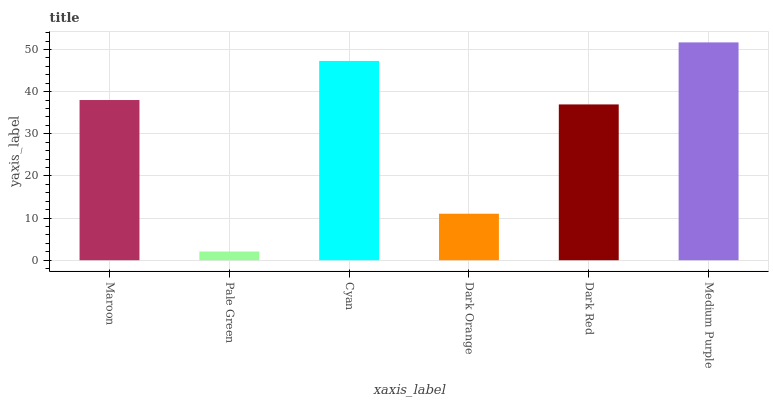Is Pale Green the minimum?
Answer yes or no. Yes. Is Medium Purple the maximum?
Answer yes or no. Yes. Is Cyan the minimum?
Answer yes or no. No. Is Cyan the maximum?
Answer yes or no. No. Is Cyan greater than Pale Green?
Answer yes or no. Yes. Is Pale Green less than Cyan?
Answer yes or no. Yes. Is Pale Green greater than Cyan?
Answer yes or no. No. Is Cyan less than Pale Green?
Answer yes or no. No. Is Maroon the high median?
Answer yes or no. Yes. Is Dark Red the low median?
Answer yes or no. Yes. Is Cyan the high median?
Answer yes or no. No. Is Maroon the low median?
Answer yes or no. No. 